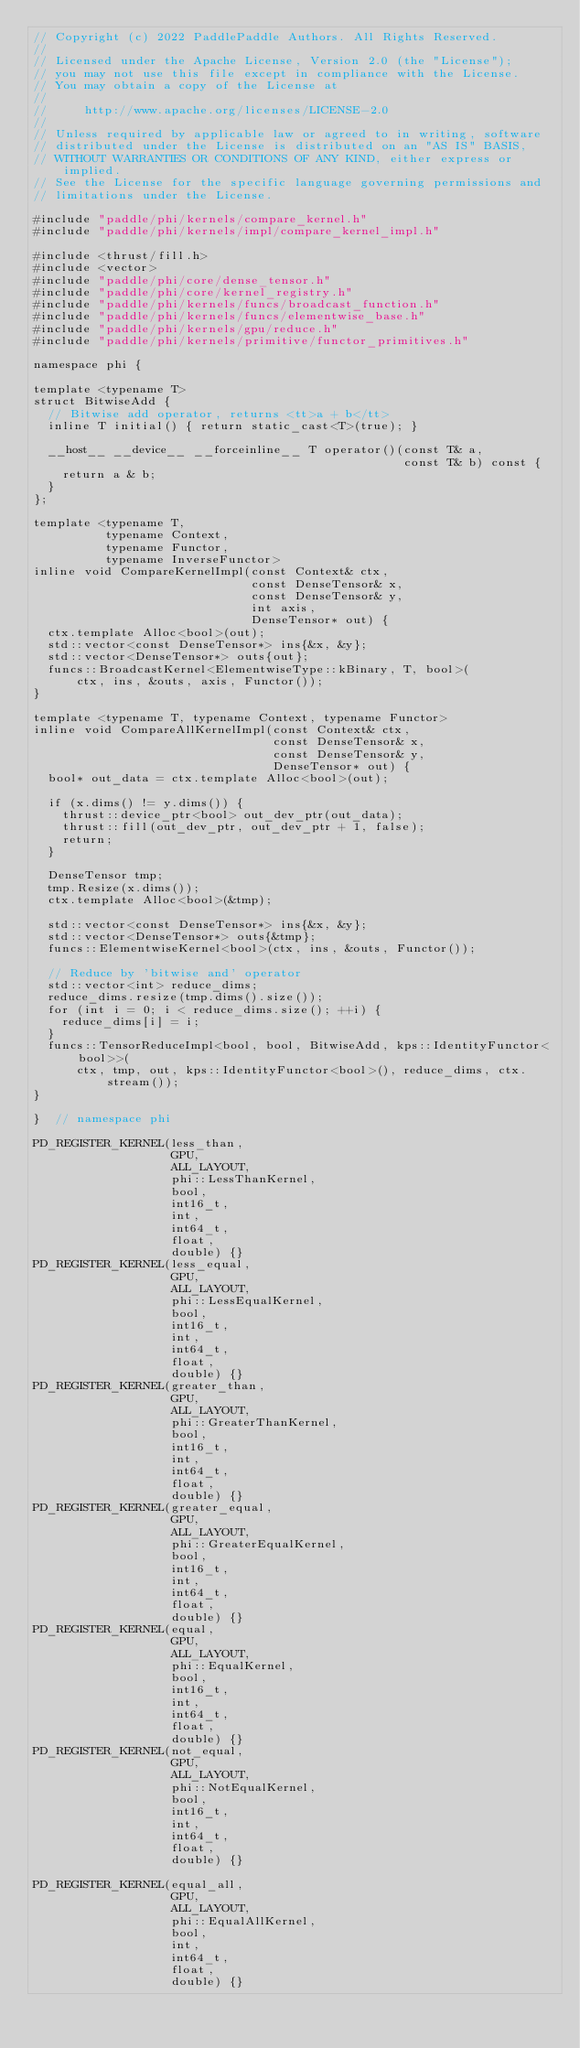<code> <loc_0><loc_0><loc_500><loc_500><_Cuda_>// Copyright (c) 2022 PaddlePaddle Authors. All Rights Reserved.
//
// Licensed under the Apache License, Version 2.0 (the "License");
// you may not use this file except in compliance with the License.
// You may obtain a copy of the License at
//
//     http://www.apache.org/licenses/LICENSE-2.0
//
// Unless required by applicable law or agreed to in writing, software
// distributed under the License is distributed on an "AS IS" BASIS,
// WITHOUT WARRANTIES OR CONDITIONS OF ANY KIND, either express or implied.
// See the License for the specific language governing permissions and
// limitations under the License.

#include "paddle/phi/kernels/compare_kernel.h"
#include "paddle/phi/kernels/impl/compare_kernel_impl.h"

#include <thrust/fill.h>
#include <vector>
#include "paddle/phi/core/dense_tensor.h"
#include "paddle/phi/core/kernel_registry.h"
#include "paddle/phi/kernels/funcs/broadcast_function.h"
#include "paddle/phi/kernels/funcs/elementwise_base.h"
#include "paddle/phi/kernels/gpu/reduce.h"
#include "paddle/phi/kernels/primitive/functor_primitives.h"

namespace phi {

template <typename T>
struct BitwiseAdd {
  // Bitwise add operator, returns <tt>a + b</tt>
  inline T initial() { return static_cast<T>(true); }

  __host__ __device__ __forceinline__ T operator()(const T& a,
                                                   const T& b) const {
    return a & b;
  }
};

template <typename T,
          typename Context,
          typename Functor,
          typename InverseFunctor>
inline void CompareKernelImpl(const Context& ctx,
                              const DenseTensor& x,
                              const DenseTensor& y,
                              int axis,
                              DenseTensor* out) {
  ctx.template Alloc<bool>(out);
  std::vector<const DenseTensor*> ins{&x, &y};
  std::vector<DenseTensor*> outs{out};
  funcs::BroadcastKernel<ElementwiseType::kBinary, T, bool>(
      ctx, ins, &outs, axis, Functor());
}

template <typename T, typename Context, typename Functor>
inline void CompareAllKernelImpl(const Context& ctx,
                                 const DenseTensor& x,
                                 const DenseTensor& y,
                                 DenseTensor* out) {
  bool* out_data = ctx.template Alloc<bool>(out);

  if (x.dims() != y.dims()) {
    thrust::device_ptr<bool> out_dev_ptr(out_data);
    thrust::fill(out_dev_ptr, out_dev_ptr + 1, false);
    return;
  }

  DenseTensor tmp;
  tmp.Resize(x.dims());
  ctx.template Alloc<bool>(&tmp);

  std::vector<const DenseTensor*> ins{&x, &y};
  std::vector<DenseTensor*> outs{&tmp};
  funcs::ElementwiseKernel<bool>(ctx, ins, &outs, Functor());

  // Reduce by 'bitwise and' operator
  std::vector<int> reduce_dims;
  reduce_dims.resize(tmp.dims().size());
  for (int i = 0; i < reduce_dims.size(); ++i) {
    reduce_dims[i] = i;
  }
  funcs::TensorReduceImpl<bool, bool, BitwiseAdd, kps::IdentityFunctor<bool>>(
      ctx, tmp, out, kps::IdentityFunctor<bool>(), reduce_dims, ctx.stream());
}

}  // namespace phi

PD_REGISTER_KERNEL(less_than,
                   GPU,
                   ALL_LAYOUT,
                   phi::LessThanKernel,
                   bool,
                   int16_t,
                   int,
                   int64_t,
                   float,
                   double) {}
PD_REGISTER_KERNEL(less_equal,
                   GPU,
                   ALL_LAYOUT,
                   phi::LessEqualKernel,
                   bool,
                   int16_t,
                   int,
                   int64_t,
                   float,
                   double) {}
PD_REGISTER_KERNEL(greater_than,
                   GPU,
                   ALL_LAYOUT,
                   phi::GreaterThanKernel,
                   bool,
                   int16_t,
                   int,
                   int64_t,
                   float,
                   double) {}
PD_REGISTER_KERNEL(greater_equal,
                   GPU,
                   ALL_LAYOUT,
                   phi::GreaterEqualKernel,
                   bool,
                   int16_t,
                   int,
                   int64_t,
                   float,
                   double) {}
PD_REGISTER_KERNEL(equal,
                   GPU,
                   ALL_LAYOUT,
                   phi::EqualKernel,
                   bool,
                   int16_t,
                   int,
                   int64_t,
                   float,
                   double) {}
PD_REGISTER_KERNEL(not_equal,
                   GPU,
                   ALL_LAYOUT,
                   phi::NotEqualKernel,
                   bool,
                   int16_t,
                   int,
                   int64_t,
                   float,
                   double) {}

PD_REGISTER_KERNEL(equal_all,
                   GPU,
                   ALL_LAYOUT,
                   phi::EqualAllKernel,
                   bool,
                   int,
                   int64_t,
                   float,
                   double) {}
</code> 